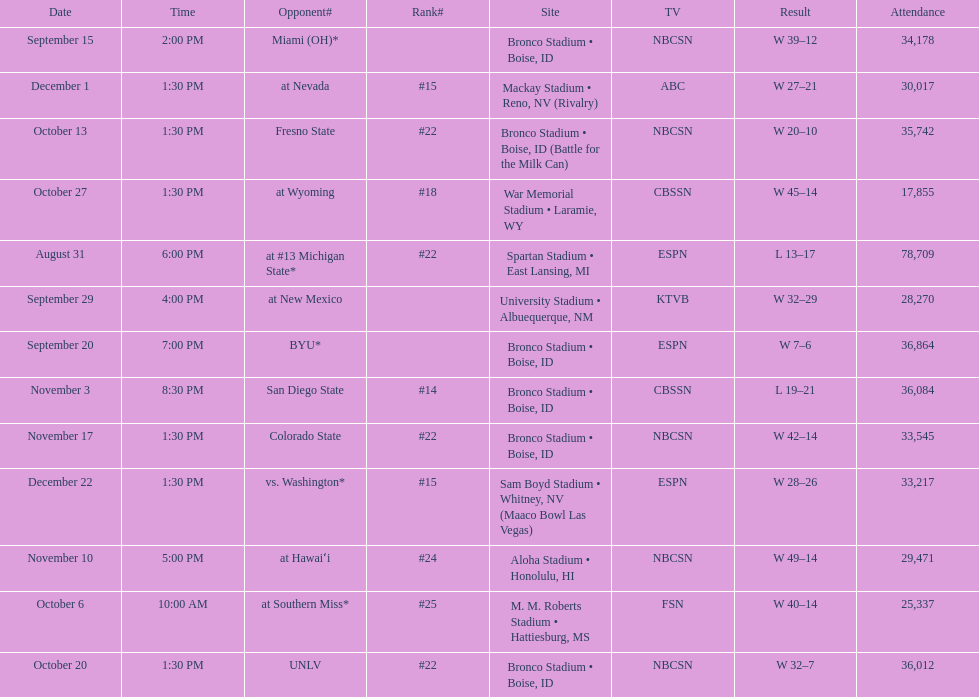What was there top ranked position of the season? #14. 